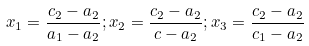<formula> <loc_0><loc_0><loc_500><loc_500>x _ { 1 } = \frac { c _ { 2 } - a _ { 2 } } { a _ { 1 } - a _ { 2 } } ; x _ { 2 } = \frac { c _ { 2 } - a _ { 2 } } { c - a _ { 2 } } ; x _ { 3 } = \frac { c _ { 2 } - a _ { 2 } } { c _ { 1 } - a _ { 2 } }</formula> 